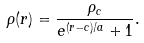<formula> <loc_0><loc_0><loc_500><loc_500>\rho ( r ) = \frac { \rho _ { c } } { e ^ { ( r - c ) / a } + 1 } .</formula> 